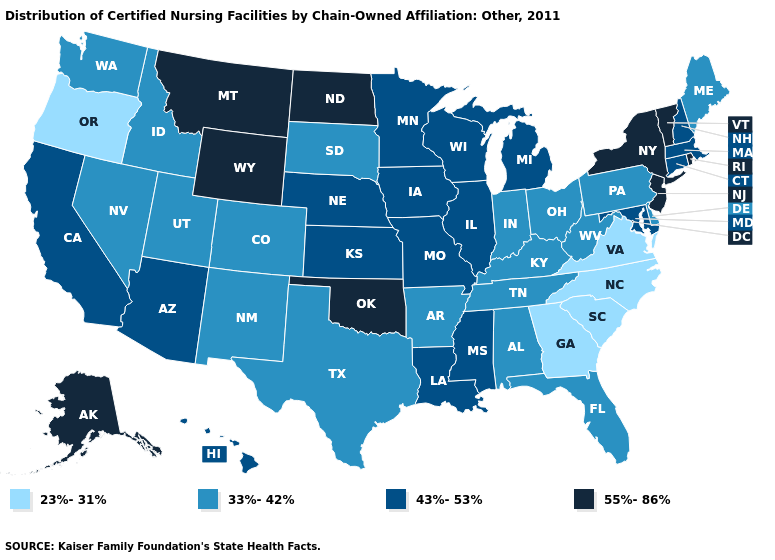Does Utah have a higher value than Virginia?
Be succinct. Yes. Is the legend a continuous bar?
Write a very short answer. No. Among the states that border Maryland , does Virginia have the highest value?
Quick response, please. No. Is the legend a continuous bar?
Concise answer only. No. Name the states that have a value in the range 55%-86%?
Be succinct. Alaska, Montana, New Jersey, New York, North Dakota, Oklahoma, Rhode Island, Vermont, Wyoming. Name the states that have a value in the range 43%-53%?
Concise answer only. Arizona, California, Connecticut, Hawaii, Illinois, Iowa, Kansas, Louisiana, Maryland, Massachusetts, Michigan, Minnesota, Mississippi, Missouri, Nebraska, New Hampshire, Wisconsin. What is the value of Indiana?
Concise answer only. 33%-42%. Name the states that have a value in the range 43%-53%?
Be succinct. Arizona, California, Connecticut, Hawaii, Illinois, Iowa, Kansas, Louisiana, Maryland, Massachusetts, Michigan, Minnesota, Mississippi, Missouri, Nebraska, New Hampshire, Wisconsin. What is the highest value in states that border Indiana?
Give a very brief answer. 43%-53%. Does the map have missing data?
Write a very short answer. No. Among the states that border Kansas , does Colorado have the lowest value?
Concise answer only. Yes. What is the value of Alabama?
Give a very brief answer. 33%-42%. Among the states that border New Hampshire , which have the highest value?
Write a very short answer. Vermont. Which states have the highest value in the USA?
Be succinct. Alaska, Montana, New Jersey, New York, North Dakota, Oklahoma, Rhode Island, Vermont, Wyoming. Name the states that have a value in the range 43%-53%?
Concise answer only. Arizona, California, Connecticut, Hawaii, Illinois, Iowa, Kansas, Louisiana, Maryland, Massachusetts, Michigan, Minnesota, Mississippi, Missouri, Nebraska, New Hampshire, Wisconsin. 